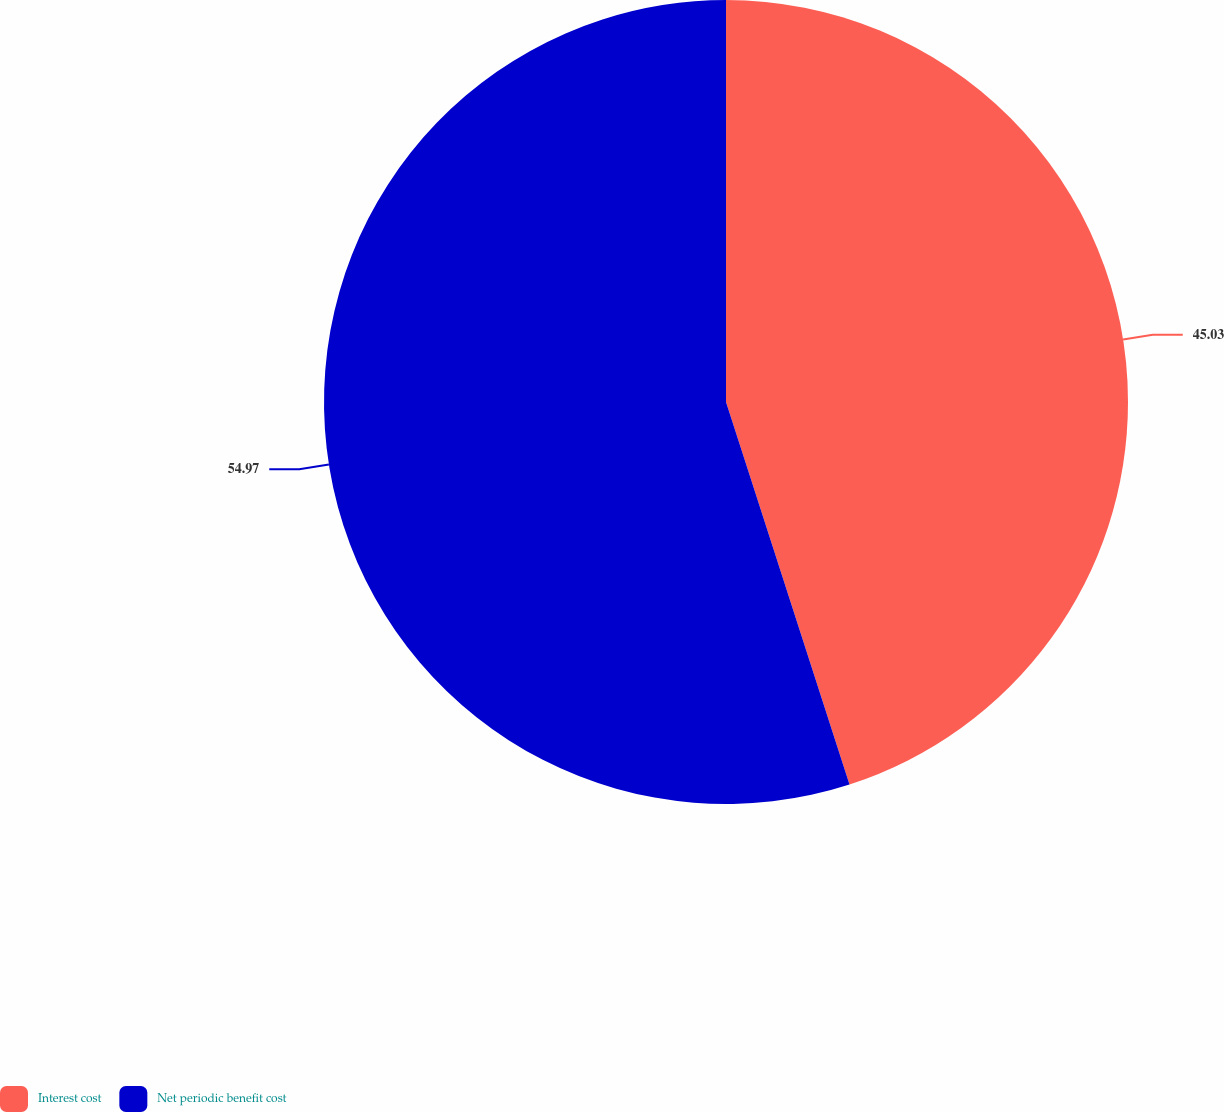Convert chart to OTSL. <chart><loc_0><loc_0><loc_500><loc_500><pie_chart><fcel>Interest cost<fcel>Net periodic benefit cost<nl><fcel>45.03%<fcel>54.97%<nl></chart> 